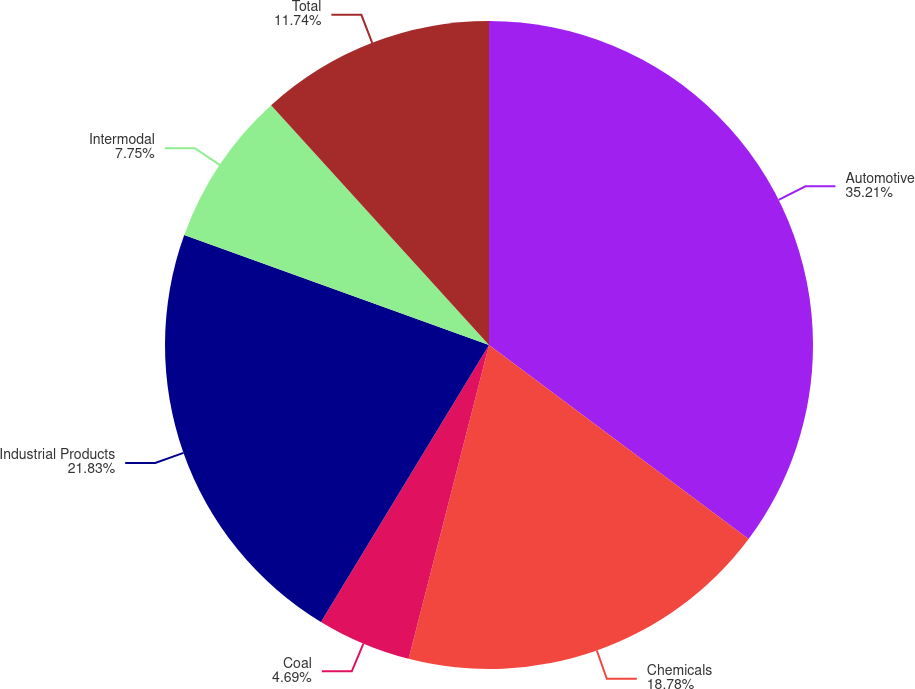Convert chart to OTSL. <chart><loc_0><loc_0><loc_500><loc_500><pie_chart><fcel>Automotive<fcel>Chemicals<fcel>Coal<fcel>Industrial Products<fcel>Intermodal<fcel>Total<nl><fcel>35.21%<fcel>18.78%<fcel>4.69%<fcel>21.83%<fcel>7.75%<fcel>11.74%<nl></chart> 